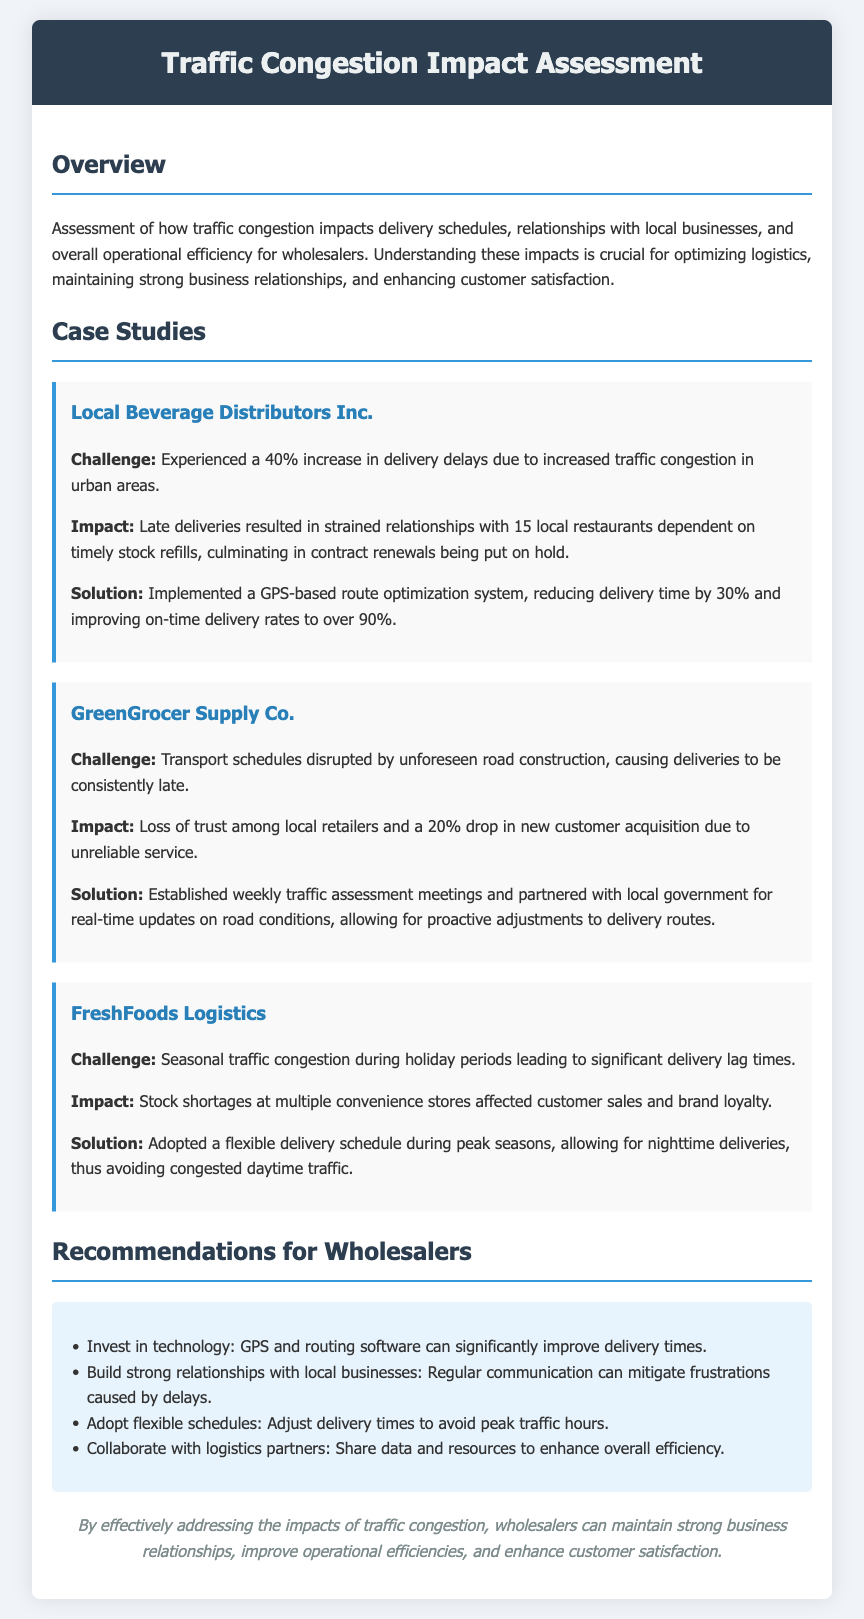what is the percentage increase in delivery delays for Local Beverage Distributors Inc.? The document states there was a 40% increase in delivery delays due to traffic congestion.
Answer: 40% how many local restaurants were affected by delivery delays from Local Beverage Distributors Inc.? The impact section mentions that 15 local restaurants were dependent on timely stock refills.
Answer: 15 what was the solution implemented by Local Beverage Distributors Inc.? The document indicates they implemented a GPS-based route optimization system to improve delivery times.
Answer: GPS-based route optimization system what was the loss of trust percentage experienced by GreenGrocer Supply Co.? The document notes a 20% drop in new customer acquisition due to unreliable service.
Answer: 20% what type of meetings did GreenGrocer Supply Co. establish for better traffic assessment? The document mentions they established weekly traffic assessment meetings.
Answer: weekly traffic assessment meetings what method did FreshFoods Logistics adopt during peak seasons? The document states they adopted a flexible delivery schedule allowing for nighttime deliveries.
Answer: flexible delivery schedule how many recommendations are provided for wholesalers in the document? The recommendations section lists four strategies for wholesalers to improve delivery times.
Answer: 4 which company experienced stock shortages affecting customer sales and brand loyalty? The document states that FreshFoods Logistics faced this issue during holiday periods.
Answer: FreshFoods Logistics what technology do the recommendations suggest wholesalers invest in? The recommendations section suggests investing in GPS and routing software.
Answer: GPS and routing software 